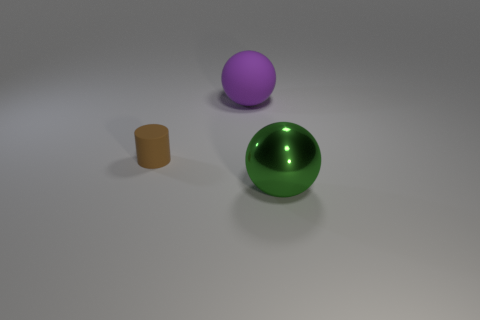Are there any other things that are the same material as the green sphere?
Your response must be concise. No. Is there any other thing that is the same size as the brown thing?
Make the answer very short. No. What number of objects are either big red rubber objects or big balls?
Your response must be concise. 2. There is a purple rubber thing; does it have the same shape as the big object that is in front of the matte sphere?
Offer a terse response. Yes. What shape is the rubber thing in front of the purple object?
Offer a very short reply. Cylinder. Does the brown thing have the same shape as the large green metallic thing?
Your answer should be compact. No. There is a ball left of the metal thing; is its size the same as the small brown rubber cylinder?
Offer a terse response. No. What size is the thing that is left of the green metal sphere and in front of the purple ball?
Your response must be concise. Small. Are there the same number of big purple rubber balls that are to the left of the tiny cylinder and tiny blue cylinders?
Your answer should be compact. Yes. What color is the small cylinder?
Your answer should be compact. Brown. 